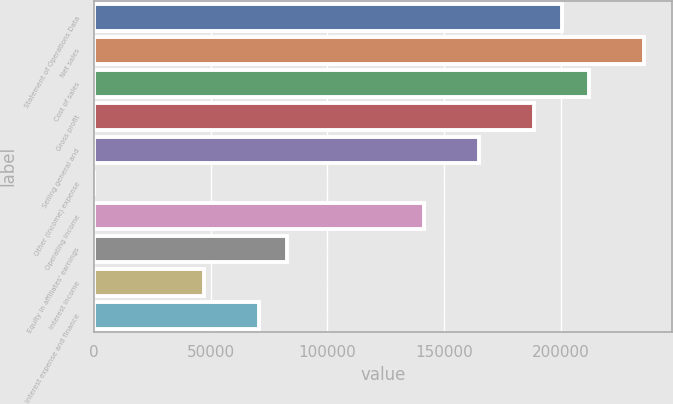Convert chart. <chart><loc_0><loc_0><loc_500><loc_500><bar_chart><fcel>Statement of Operations Data<fcel>Net sales<fcel>Cost of sales<fcel>Gross profit<fcel>Selling general and<fcel>Other (income) expense<fcel>Operating income<fcel>Equity in affiliates' earnings<fcel>Interest income<fcel>Interest expense and finance<nl><fcel>200328<fcel>235680<fcel>212112<fcel>188544<fcel>164976<fcel>0.1<fcel>141408<fcel>82488<fcel>47136.1<fcel>70704<nl></chart> 